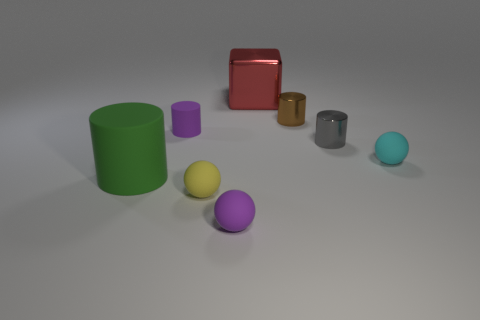What is the material of the small ball that is the same color as the tiny rubber cylinder?
Offer a very short reply. Rubber. What number of other things are there of the same color as the tiny matte cylinder?
Your answer should be very brief. 1. Is the size of the rubber ball that is left of the purple sphere the same as the gray metallic thing?
Offer a very short reply. Yes. What number of metallic things are either large cyan cylinders or tiny brown objects?
Offer a terse response. 1. There is a rubber thing that is in front of the tiny yellow rubber sphere; what is its size?
Give a very brief answer. Small. Do the tiny cyan matte thing and the tiny yellow object have the same shape?
Provide a short and direct response. Yes. What number of tiny things are either metal things or yellow rubber spheres?
Ensure brevity in your answer.  3. Are there any balls to the right of the purple ball?
Your response must be concise. Yes. Are there an equal number of small purple cylinders right of the cyan ball and tiny red rubber cylinders?
Ensure brevity in your answer.  Yes. What is the size of the green thing that is the same shape as the tiny brown metallic object?
Offer a terse response. Large. 